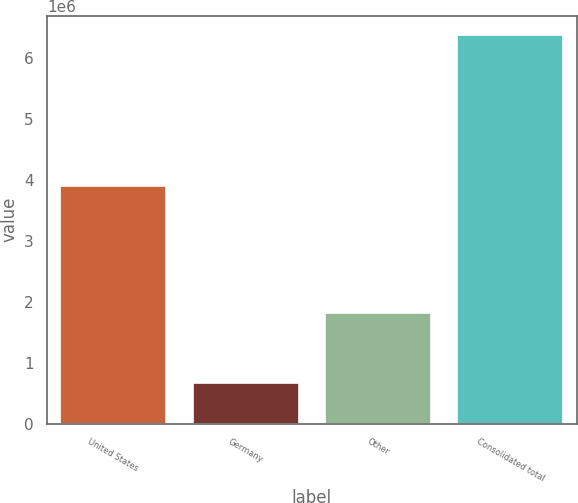<chart> <loc_0><loc_0><loc_500><loc_500><bar_chart><fcel>United States<fcel>Germany<fcel>Other<fcel>Consolidated total<nl><fcel>3.89752e+06<fcel>671341<fcel>1.81155e+06<fcel>6.38041e+06<nl></chart> 